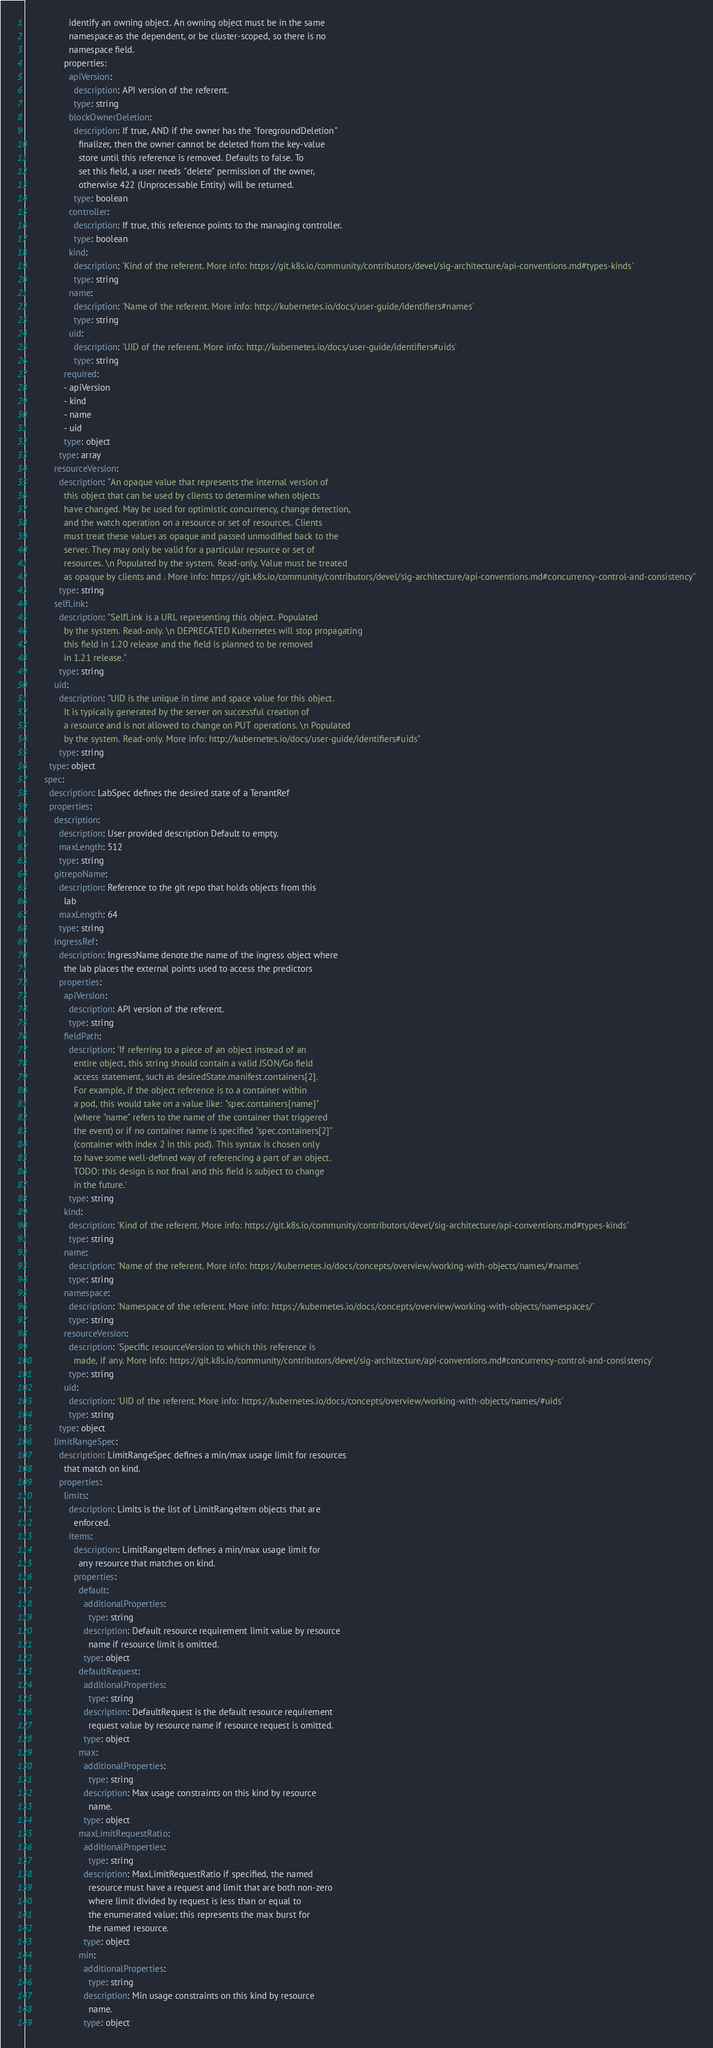<code> <loc_0><loc_0><loc_500><loc_500><_YAML_>                  identify an owning object. An owning object must be in the same
                  namespace as the dependent, or be cluster-scoped, so there is no
                  namespace field.
                properties:
                  apiVersion:
                    description: API version of the referent.
                    type: string
                  blockOwnerDeletion:
                    description: If true, AND if the owner has the "foregroundDeletion"
                      finalizer, then the owner cannot be deleted from the key-value
                      store until this reference is removed. Defaults to false. To
                      set this field, a user needs "delete" permission of the owner,
                      otherwise 422 (Unprocessable Entity) will be returned.
                    type: boolean
                  controller:
                    description: If true, this reference points to the managing controller.
                    type: boolean
                  kind:
                    description: 'Kind of the referent. More info: https://git.k8s.io/community/contributors/devel/sig-architecture/api-conventions.md#types-kinds'
                    type: string
                  name:
                    description: 'Name of the referent. More info: http://kubernetes.io/docs/user-guide/identifiers#names'
                    type: string
                  uid:
                    description: 'UID of the referent. More info: http://kubernetes.io/docs/user-guide/identifiers#uids'
                    type: string
                required:
                - apiVersion
                - kind
                - name
                - uid
                type: object
              type: array
            resourceVersion:
              description: "An opaque value that represents the internal version of
                this object that can be used by clients to determine when objects
                have changed. May be used for optimistic concurrency, change detection,
                and the watch operation on a resource or set of resources. Clients
                must treat these values as opaque and passed unmodified back to the
                server. They may only be valid for a particular resource or set of
                resources. \n Populated by the system. Read-only. Value must be treated
                as opaque by clients and . More info: https://git.k8s.io/community/contributors/devel/sig-architecture/api-conventions.md#concurrency-control-and-consistency"
              type: string
            selfLink:
              description: "SelfLink is a URL representing this object. Populated
                by the system. Read-only. \n DEPRECATED Kubernetes will stop propagating
                this field in 1.20 release and the field is planned to be removed
                in 1.21 release."
              type: string
            uid:
              description: "UID is the unique in time and space value for this object.
                It is typically generated by the server on successful creation of
                a resource and is not allowed to change on PUT operations. \n Populated
                by the system. Read-only. More info: http://kubernetes.io/docs/user-guide/identifiers#uids"
              type: string
          type: object
        spec:
          description: LabSpec defines the desired state of a TenantRef
          properties:
            description:
              description: User provided description Default to empty.
              maxLength: 512
              type: string
            gitrepoName:
              description: Reference to the git repo that holds objects from this
                lab
              maxLength: 64
              type: string
            ingressRef:
              description: IngressName denote the name of the ingress object where
                the lab places the external points used to access the predictors
              properties:
                apiVersion:
                  description: API version of the referent.
                  type: string
                fieldPath:
                  description: 'If referring to a piece of an object instead of an
                    entire object, this string should contain a valid JSON/Go field
                    access statement, such as desiredState.manifest.containers[2].
                    For example, if the object reference is to a container within
                    a pod, this would take on a value like: "spec.containers{name}"
                    (where "name" refers to the name of the container that triggered
                    the event) or if no container name is specified "spec.containers[2]"
                    (container with index 2 in this pod). This syntax is chosen only
                    to have some well-defined way of referencing a part of an object.
                    TODO: this design is not final and this field is subject to change
                    in the future.'
                  type: string
                kind:
                  description: 'Kind of the referent. More info: https://git.k8s.io/community/contributors/devel/sig-architecture/api-conventions.md#types-kinds'
                  type: string
                name:
                  description: 'Name of the referent. More info: https://kubernetes.io/docs/concepts/overview/working-with-objects/names/#names'
                  type: string
                namespace:
                  description: 'Namespace of the referent. More info: https://kubernetes.io/docs/concepts/overview/working-with-objects/namespaces/'
                  type: string
                resourceVersion:
                  description: 'Specific resourceVersion to which this reference is
                    made, if any. More info: https://git.k8s.io/community/contributors/devel/sig-architecture/api-conventions.md#concurrency-control-and-consistency'
                  type: string
                uid:
                  description: 'UID of the referent. More info: https://kubernetes.io/docs/concepts/overview/working-with-objects/names/#uids'
                  type: string
              type: object
            limitRangeSpec:
              description: LimitRangeSpec defines a min/max usage limit for resources
                that match on kind.
              properties:
                limits:
                  description: Limits is the list of LimitRangeItem objects that are
                    enforced.
                  items:
                    description: LimitRangeItem defines a min/max usage limit for
                      any resource that matches on kind.
                    properties:
                      default:
                        additionalProperties:
                          type: string
                        description: Default resource requirement limit value by resource
                          name if resource limit is omitted.
                        type: object
                      defaultRequest:
                        additionalProperties:
                          type: string
                        description: DefaultRequest is the default resource requirement
                          request value by resource name if resource request is omitted.
                        type: object
                      max:
                        additionalProperties:
                          type: string
                        description: Max usage constraints on this kind by resource
                          name.
                        type: object
                      maxLimitRequestRatio:
                        additionalProperties:
                          type: string
                        description: MaxLimitRequestRatio if specified, the named
                          resource must have a request and limit that are both non-zero
                          where limit divided by request is less than or equal to
                          the enumerated value; this represents the max burst for
                          the named resource.
                        type: object
                      min:
                        additionalProperties:
                          type: string
                        description: Min usage constraints on this kind by resource
                          name.
                        type: object</code> 